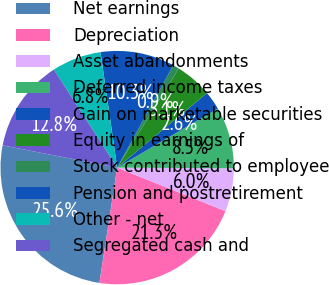Convert chart. <chart><loc_0><loc_0><loc_500><loc_500><pie_chart><fcel>Net earnings<fcel>Depreciation<fcel>Asset abandonments<fcel>Deferred income taxes<fcel>Gain on marketable securities<fcel>Equity in earnings of<fcel>Stock contributed to employee<fcel>Pension and postretirement<fcel>Other - net<fcel>Segregated cash and<nl><fcel>25.62%<fcel>21.35%<fcel>5.99%<fcel>8.55%<fcel>2.57%<fcel>5.13%<fcel>0.87%<fcel>10.26%<fcel>6.84%<fcel>12.82%<nl></chart> 